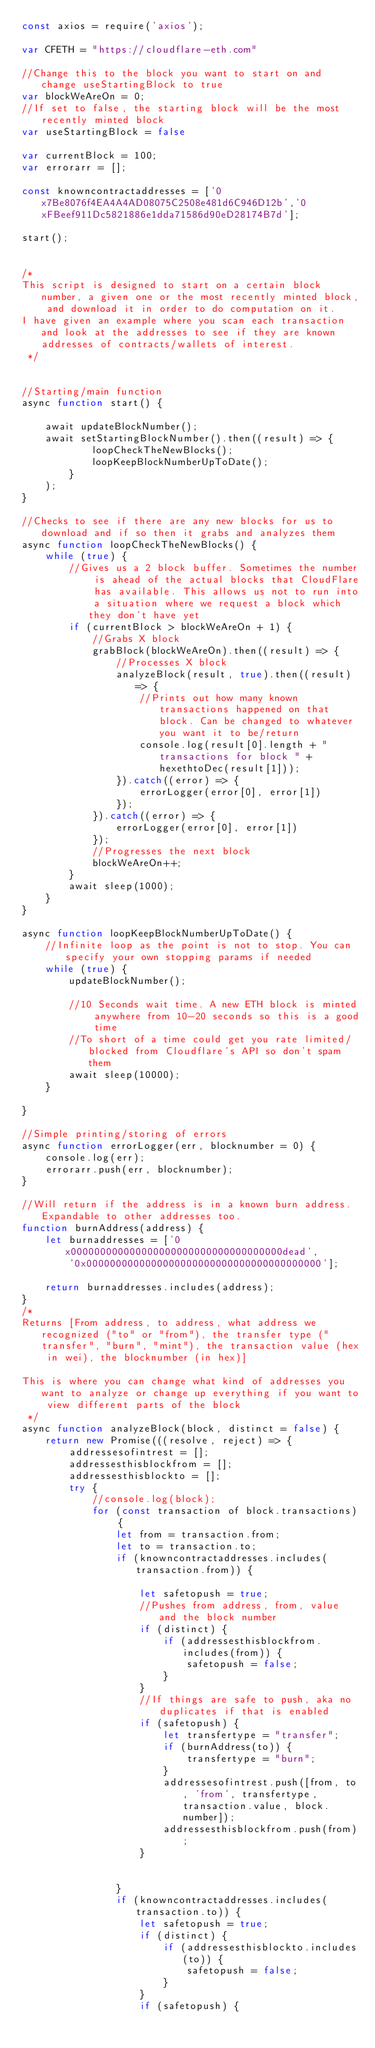<code> <loc_0><loc_0><loc_500><loc_500><_JavaScript_>const axios = require('axios');

var CFETH = "https://cloudflare-eth.com"

//Change this to the block you want to start on and change useStartingBlock to true
var blockWeAreOn = 0;
//If set to false, the starting block will be the most recently minted block
var useStartingBlock = false

var currentBlock = 100;
var errorarr = [];

const knowncontractaddresses = ['0x7Be8076f4EA4A4AD08075C2508e481d6C946D12b','0xFBeef911Dc5821886e1dda71586d90eD28174B7d'];

start();


/*
This script is designed to start on a certain block number, a given one or the most recently minted block, and download it in order to do computation on it.
I have given an example where you scan each transaction and look at the addresses to see if they are known addresses of contracts/wallets of interest.
 */


//Starting/main function
async function start() {

    await updateBlockNumber();
    await setStartingBlockNumber().then((result) => {
            loopCheckTheNewBlocks();
            loopKeepBlockNumberUpToDate();
        }
    );
}

//Checks to see if there are any new blocks for us to download and if so then it grabs and analyzes them
async function loopCheckTheNewBlocks() {
    while (true) {
        //Gives us a 2 block buffer. Sometimes the number is ahead of the actual blocks that CloudFlare has available. This allows us not to run into a situation where we request a block which they don't have yet
        if (currentBlock > blockWeAreOn + 1) {
            //Grabs X block
            grabBlock(blockWeAreOn).then((result) => {
                //Processes X block
                analyzeBlock(result, true).then((result) => {
                    //Prints out how many known transactions happened on that block. Can be changed to whatever you want it to be/return
                    console.log(result[0].length + " transactions for block " + hexethtoDec(result[1]));
                }).catch((error) => {
                    errorLogger(error[0], error[1])
                });
            }).catch((error) => {
                errorLogger(error[0], error[1])
            });
            //Progresses the next block
            blockWeAreOn++;
        }
        await sleep(1000);
    }
}

async function loopKeepBlockNumberUpToDate() {
    //Infinite loop as the point is not to stop. You can specify your own stopping params if needed
    while (true) {
        updateBlockNumber();

        //10 Seconds wait time. A new ETH block is minted anywhere from 10-20 seconds so this is a good time
        //To short of a time could get you rate limited/blocked from Cloudflare's API so don't spam them
        await sleep(10000);
    }

}

//Simple printing/storing of errors
async function errorLogger(err, blocknumber = 0) {
    console.log(err);
    errorarr.push(err, blocknumber);
}

//Will return if the address is in a known burn address. Expandable to other addresses too.
function burnAddress(address) {
    let burnaddresses = ['0x000000000000000000000000000000000000dead',
        '0x0000000000000000000000000000000000000000'];

    return burnaddresses.includes(address);
}
/*
Returns [From address, to address, what address we recognized ("to" or "from"), the transfer type ("transfer", "burn", "mint"), the transaction value (hex in wei), the blocknumber (in hex)]

This is where you can change what kind of addresses you want to analyze or change up everything if you want to view different parts of the block
 */
async function analyzeBlock(block, distinct = false) {
    return new Promise(((resolve, reject) => {
        addressesofintrest = [];
        addressesthisblockfrom = [];
        addressesthisblockto = [];
        try {
            //console.log(block);
            for (const transaction of block.transactions) {
                let from = transaction.from;
                let to = transaction.to;
                if (knowncontractaddresses.includes(transaction.from)) {

                    let safetopush = true;
                    //Pushes from address, from, value and the block number
                    if (distinct) {
                        if (addressesthisblockfrom.includes(from)) {
                            safetopush = false;
                        }
                    }
                    //If things are safe to push, aka no duplicates if that is enabled
                    if (safetopush) {
                        let transfertype = "transfer";
                        if (burnAddress(to)) {
                            transfertype = "burn";
                        }
                        addressesofintrest.push([from, to, 'from', transfertype, transaction.value, block.number]);
                        addressesthisblockfrom.push(from);
                    }


                }
                if (knowncontractaddresses.includes(transaction.to)) {
                    let safetopush = true;
                    if (distinct) {
                        if (addressesthisblockto.includes(to)) {
                            safetopush = false;
                        }
                    }
                    if (safetopush) {</code> 